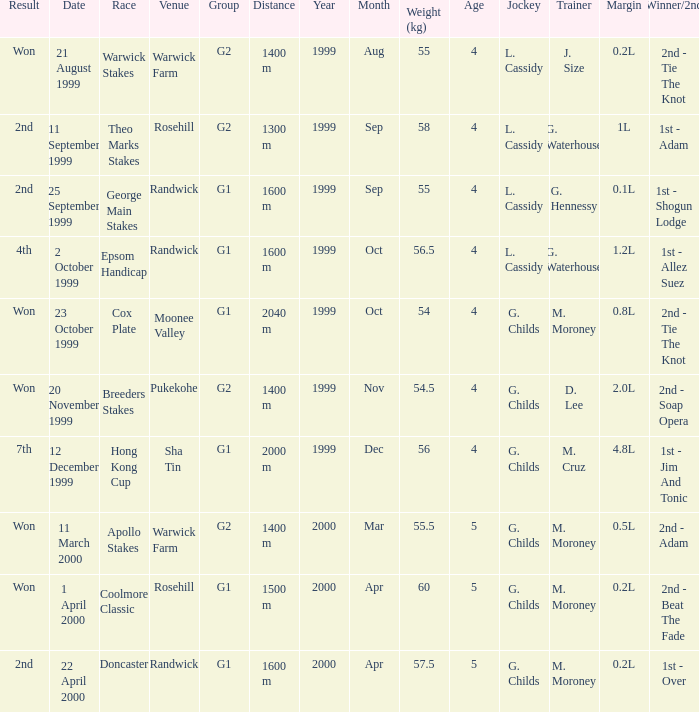How man teams had a total weight of 57.5? 1.0. 